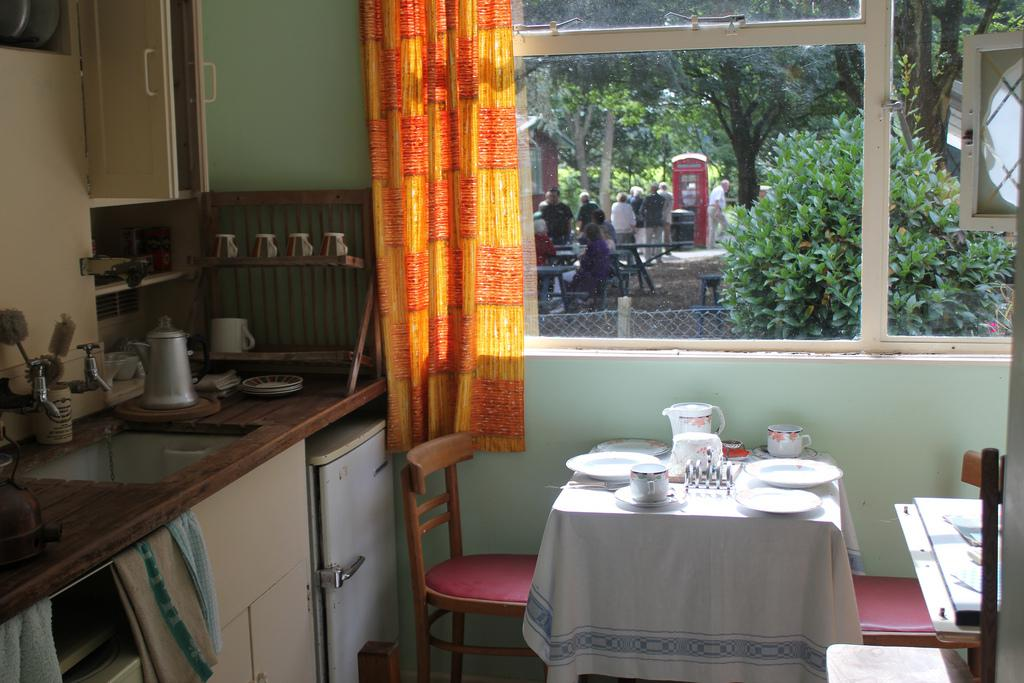Question: where is this scene taking place?
Choices:
A. In the kitchen.
B. In the bedroom.
C. In the garage.
D. In the bathroom.
Answer with the letter. Answer: A Question: what do the people outside the window appear to be doing?
Choices:
A. Yelling.
B. Talking.
C. Working.
D. Running.
Answer with the letter. Answer: B Question: what can be seen on either side of the table?
Choices:
A. Two chairs.
B. Silverware.
C. Napkins.
D. Placemats.
Answer with the letter. Answer: A Question: where can the colors pale green and orange be seen in the kitchen?
Choices:
A. The refrigerator.
B. The wall and curtain.
C. The dishes.
D. The table.
Answer with the letter. Answer: B Question: what does the kitchen table appear to be?
Choices:
A. Set.
B. Glass.
C. Oak.
D. Old.
Answer with the letter. Answer: A Question: what seems to be shining on the curtain to make it a brighter color?
Choices:
A. The sun.
B. The light.
C. A candle.
D. The moon.
Answer with the letter. Answer: A Question: how is the cabinet door positioned?
Choices:
A. Open.
B. Closed.
C. Broken off.
D. Awkwardly.
Answer with the letter. Answer: A Question: what is the weather like?
Choices:
A. Partly cloudy and cool.
B. Sunny and breezy.
C. Sunny and calm.
D. Rainy and windy.
Answer with the letter. Answer: C Question: what can you see out the window?
Choices:
A. Sunlight.
B. Trees.
C. Native flora.
D. That it's daytime.
Answer with the letter. Answer: D Question: what size is the refrigerator?
Choices:
A. Small.
B. Medium.
C. 17 cubic feet.
D. Large.
Answer with the letter. Answer: A Question: what is on the counter?
Choices:
A. A blender.
B. A coffee pot.
C. A toaster.
D. Dirty dishes.
Answer with the letter. Answer: B Question: what kind of picture is this?
Choices:
A. A portrait.
B. An indoor picture.
C. A landscape.
D. A still life.
Answer with the letter. Answer: B Question: what is in the shape of a square?
Choices:
A. A small table.
B. A vinyl record jacket.
C. A box.
D. A window.
Answer with the letter. Answer: A 